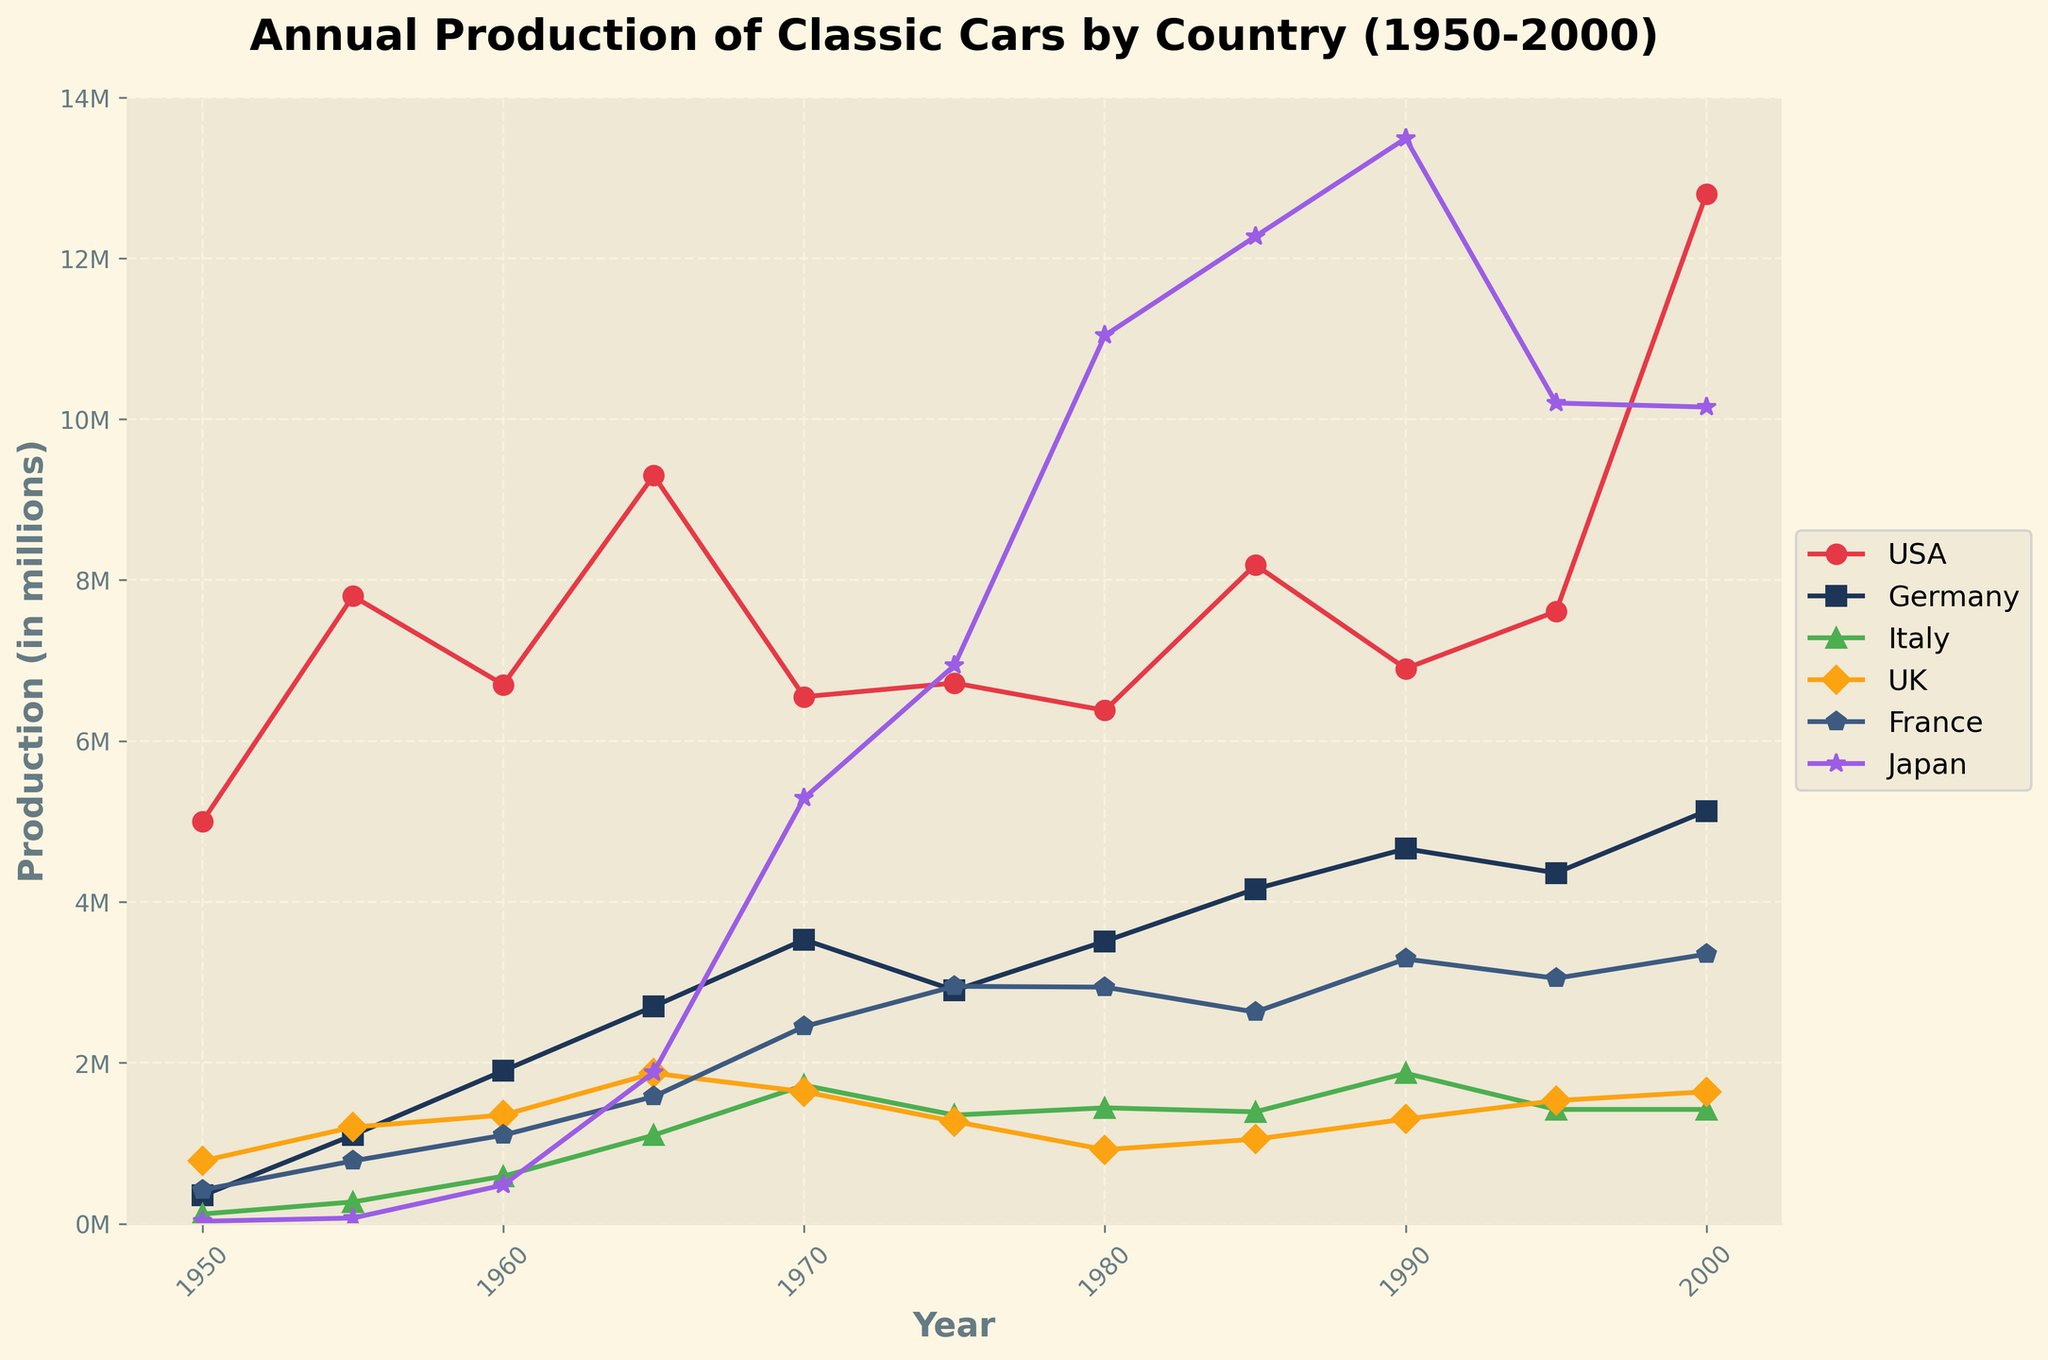Which country had the highest car production in 1980? Observing the line chart for the year 1980, the country with the highest production is Japan.
Answer: Japan How did the car production in the USA change from 1950 to 2000? The car production in the USA increased from 5,000,000 in 1950 to 12,800,000 in 2000. This indicates a significant growth over the 50-year period.
Answer: Increased Which two countries had the closest car production numbers in 1965? In 1965, examining the production numbers on the plot shows the UK (1,870,000) and Italy (1,100,000) had the closest production numbers compared to others.
Answer: UK and Italy What was the difference in car production between Germany and France in 1970? In 1970, Germany produced 3,530,000 cars, and France produced 2,450,000 cars. The difference is 3,530,000 - 2,450,000 = 1,080,000.
Answer: 1,080,000 Which country showed the most stable production trend from 1950 to 2000? Observing the lines, Germany shows a relatively stable upward trend with fewer fluctuations compared to other countries.
Answer: Germany In which year did Japan surpass the USA in car production for the first time? Looking at the intersecting points of the lines for Japan and the USA, Japan surpassed the USA in car production in 1980.
Answer: 1980 What is the average annual car production in Italy over the 50-year period? Summing the production numbers for Italy from 1950 to 2000 yields: 120,000 + 270,000 + 590,000 + 1,100,000 + 1,720,000 + 1,350,000 + 1,440,000 + 1,390,000 + 1,870,000 + 1,420,000 + 1,420,000 = 12,690,000. The period is 11 years (since every five years), so average = 12,690,000 / 11 = 1,153,636.36.
Answer: 1,153,636.36 Which country had the most significant decrease in production between any two consecutive time points shown? By examining the slopes of the lines, the UK had the most significant decrease between 1980 and 1985, dropping from 920,000 to 1,050,000.
Answer: UK (1980-1985) How did the production numbers of France compare to those of the UK in 1990? In 1990, France produced 3,290,000 cars, while the UK produced 1,300,000 cars. France's production was significantly higher.
Answer: France produced more Which country had a peak in production around the mid-1970s? Observing the peaks on the plot, Japan had a significant peak around the mid-1970s.
Answer: Japan 